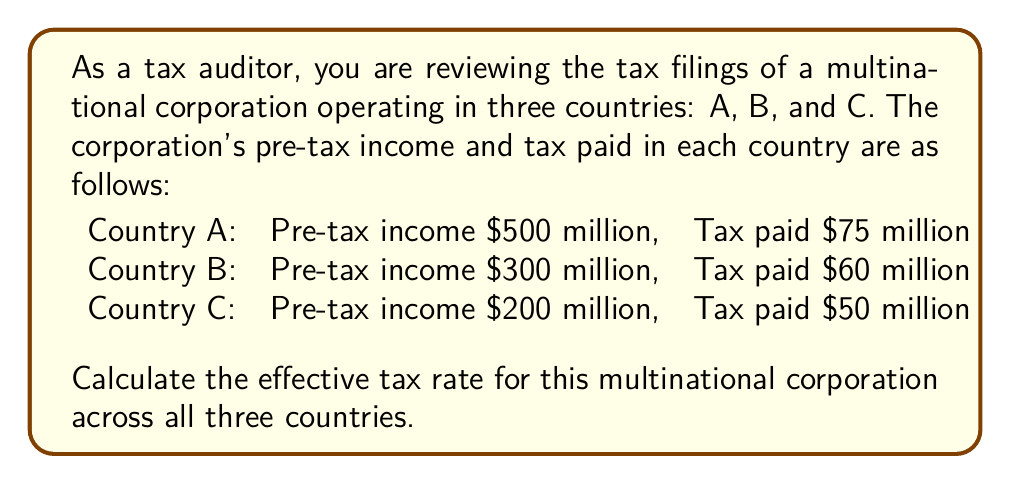Solve this math problem. To calculate the effective tax rate for the multinational corporation, we need to follow these steps:

1. Calculate the total pre-tax income:
   $$\text{Total Pre-tax Income} = 500 + 300 + 200 = 1000 \text{ million dollars}$$

2. Calculate the total tax paid:
   $$\text{Total Tax Paid} = 75 + 60 + 50 = 185 \text{ million dollars}$$

3. Calculate the effective tax rate using the formula:
   $$\text{Effective Tax Rate} = \frac{\text{Total Tax Paid}}{\text{Total Pre-tax Income}} \times 100\%$$

4. Substitute the values:
   $$\text{Effective Tax Rate} = \frac{185}{1000} \times 100\%$$

5. Perform the division:
   $$\text{Effective Tax Rate} = 0.185 \times 100\% = 18.5\%$$

The effective tax rate is the percentage of the corporation's total pre-tax income that is paid in taxes across all jurisdictions. This rate provides a comprehensive view of the company's tax burden, taking into account the varying tax rates and regulations in different countries.
Answer: The effective tax rate for the multinational corporation across all three countries is 18.5%. 